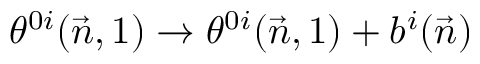<formula> <loc_0><loc_0><loc_500><loc_500>\theta ^ { 0 i } ( \vec { n } , 1 ) \to \theta ^ { 0 i } ( \vec { n } , 1 ) + b ^ { i } ( \vec { n } )</formula> 